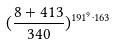<formula> <loc_0><loc_0><loc_500><loc_500>( \frac { 8 + 4 1 3 } { 3 4 0 } ) ^ { 1 9 1 ^ { 9 } \cdot 1 6 3 }</formula> 